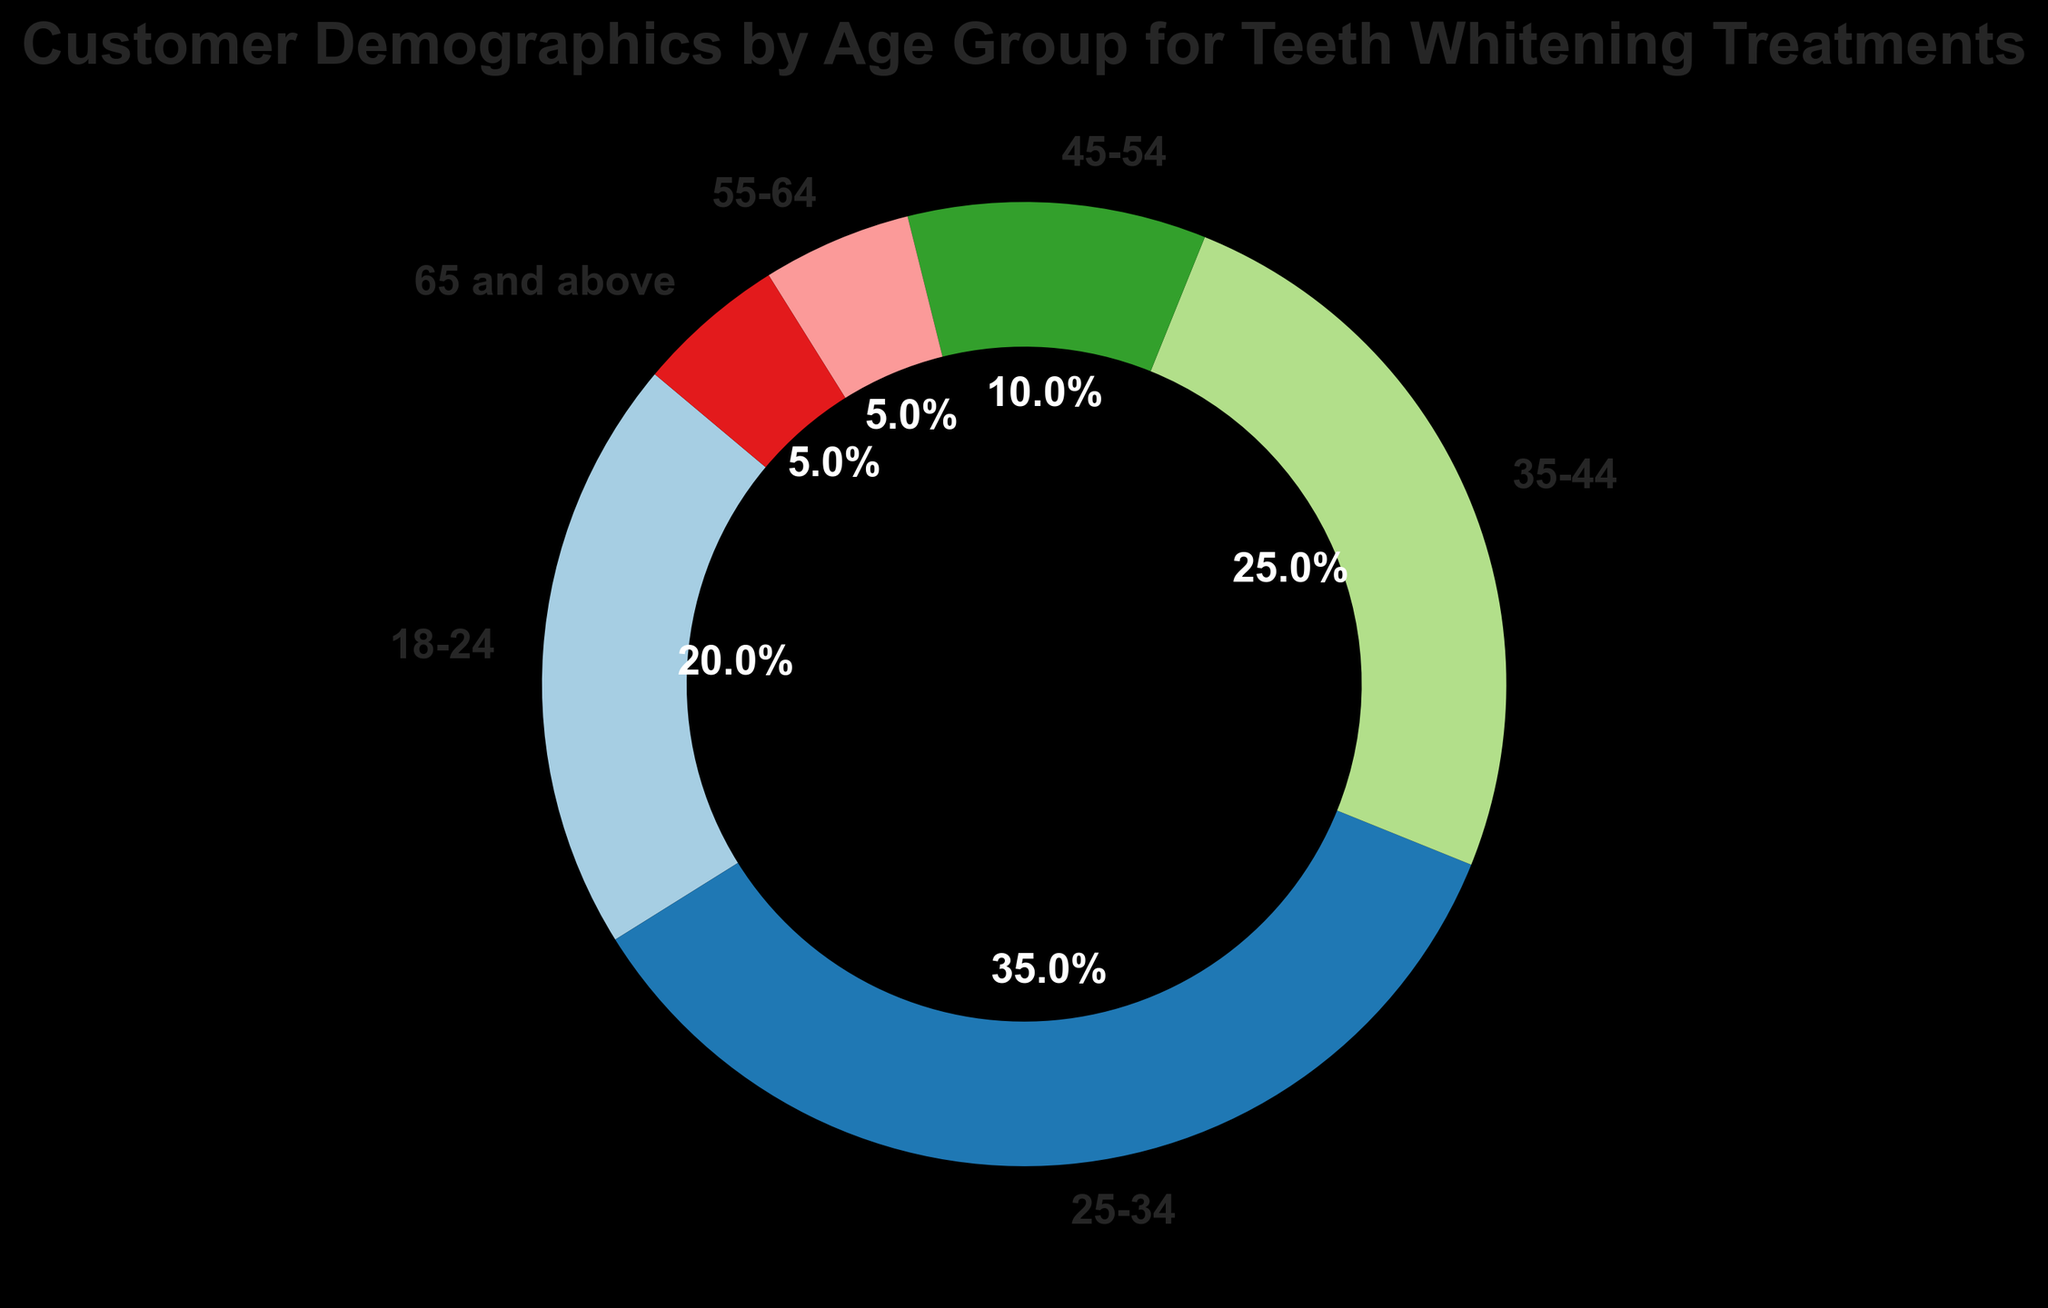What's the largest age group for teeth whitening treatments? The largest age group is determined by the highest percentage in the pie chart. The 25-34 age group has the highest percentage at 35%.
Answer: 25-34 Which two age groups have the same percentage of customers? By examining the pie chart, we can see that the 55-64 and 65 and above age groups both have a percentage of 5%.
Answer: 55-64 and 65 and above What is the combined percentage of customers under the age of 35? Add the percentages for the age groups 18-24 (20%) and 25-34 (35%). The combined percentage is 20 + 35 = 55%.
Answer: 55% What is the difference in percentage between the 35-44 and 45-54 age groups? Subtract the percentage of the 45-54 age group (10%) from the 35-44 age group (25%). The difference is 25 - 10 = 15%.
Answer: 15% Which age group accounts for exactly one-fourth of the customers? One-fourth corresponds to 25%. The age group that accounts for this percentage is the 35-44 age group.
Answer: 35-44 What percentage of customers are aged 45 and above? Add the percentages for the age groups 45-54 (10%), 55-64 (5%), and 65 and above (5%). The combined percentage is 10 + 5 + 5 = 20%.
Answer: 20% Is the 18-24 age group larger or smaller than the 35-44 age group? By how much? Compare the percentages for the 18-24 age group (20%) and the 35-44 age group (25%). The 18-24 age group is smaller by 25 - 20 = 5%.
Answer: Smaller by 5% Which age group has the smallest percentage of customers, and what is it? The smallest percentage is the lowest value in the pie chart. The age groups 55-64 and 65 and above both have the smallest percentage at 5%.
Answer: 55-64 and 65 and above, 5% What is the percentage difference between the age groups with the highest and lowest customer percentages? The age group with the highest percentage is 25-34 (35%), and the lowest percentage is shared by 55-64 and 65 and above (5%). The difference is 35 - 5 = 30%.
Answer: 30% 